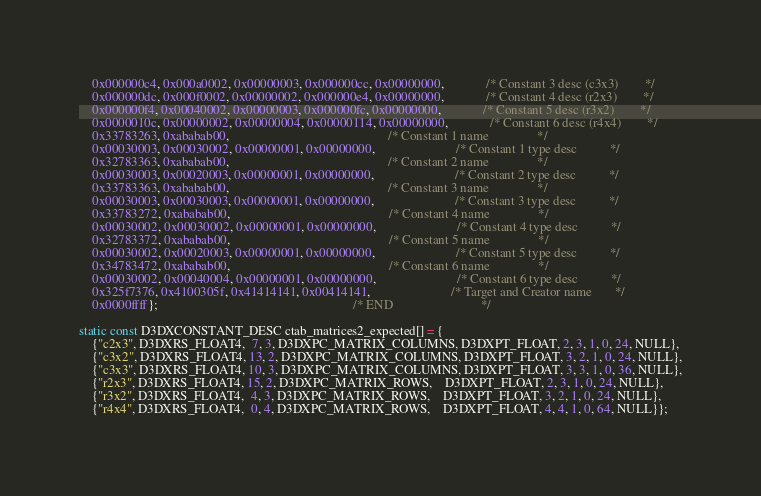<code> <loc_0><loc_0><loc_500><loc_500><_C_>    0x000000c4, 0x000a0002, 0x00000003, 0x000000cc, 0x00000000,             /* Constant 3 desc (c3x3)        */
    0x000000dc, 0x000f0002, 0x00000002, 0x000000e4, 0x00000000,             /* Constant 4 desc (r2x3)        */
    0x000000f4, 0x00040002, 0x00000003, 0x000000fc, 0x00000000,             /* Constant 5 desc (r3x2)        */
    0x0000010c, 0x00000002, 0x00000004, 0x00000114, 0x00000000,             /* Constant 6 desc (r4x4)        */
    0x33783263, 0xababab00,                                                 /* Constant 1 name               */
    0x00030003, 0x00030002, 0x00000001, 0x00000000,                         /* Constant 1 type desc          */
    0x32783363, 0xababab00,                                                 /* Constant 2 name               */
    0x00030003, 0x00020003, 0x00000001, 0x00000000,                         /* Constant 2 type desc          */
    0x33783363, 0xababab00,                                                 /* Constant 3 name               */
    0x00030003, 0x00030003, 0x00000001, 0x00000000,                         /* Constant 3 type desc          */
    0x33783272, 0xababab00,                                                 /* Constant 4 name               */
    0x00030002, 0x00030002, 0x00000001, 0x00000000,                         /* Constant 4 type desc          */
    0x32783372, 0xababab00,                                                 /* Constant 5 name               */
    0x00030002, 0x00020003, 0x00000001, 0x00000000,                         /* Constant 5 type desc          */
    0x34783472, 0xababab00,                                                 /* Constant 6 name               */
    0x00030002, 0x00040004, 0x00000001, 0x00000000,                         /* Constant 6 type desc          */
    0x325f7376, 0x4100305f, 0x41414141, 0x00414141,                         /* Target and Creator name       */
    0x0000ffff};                                                            /* END                           */

static const D3DXCONSTANT_DESC ctab_matrices2_expected[] = {
    {"c2x3", D3DXRS_FLOAT4,  7, 3, D3DXPC_MATRIX_COLUMNS, D3DXPT_FLOAT, 2, 3, 1, 0, 24, NULL},
    {"c3x2", D3DXRS_FLOAT4, 13, 2, D3DXPC_MATRIX_COLUMNS, D3DXPT_FLOAT, 3, 2, 1, 0, 24, NULL},
    {"c3x3", D3DXRS_FLOAT4, 10, 3, D3DXPC_MATRIX_COLUMNS, D3DXPT_FLOAT, 3, 3, 1, 0, 36, NULL},
    {"r2x3", D3DXRS_FLOAT4, 15, 2, D3DXPC_MATRIX_ROWS,    D3DXPT_FLOAT, 2, 3, 1, 0, 24, NULL},
    {"r3x2", D3DXRS_FLOAT4,  4, 3, D3DXPC_MATRIX_ROWS,    D3DXPT_FLOAT, 3, 2, 1, 0, 24, NULL},
    {"r4x4", D3DXRS_FLOAT4,  0, 4, D3DXPC_MATRIX_ROWS,    D3DXPT_FLOAT, 4, 4, 1, 0, 64, NULL}};
</code> 